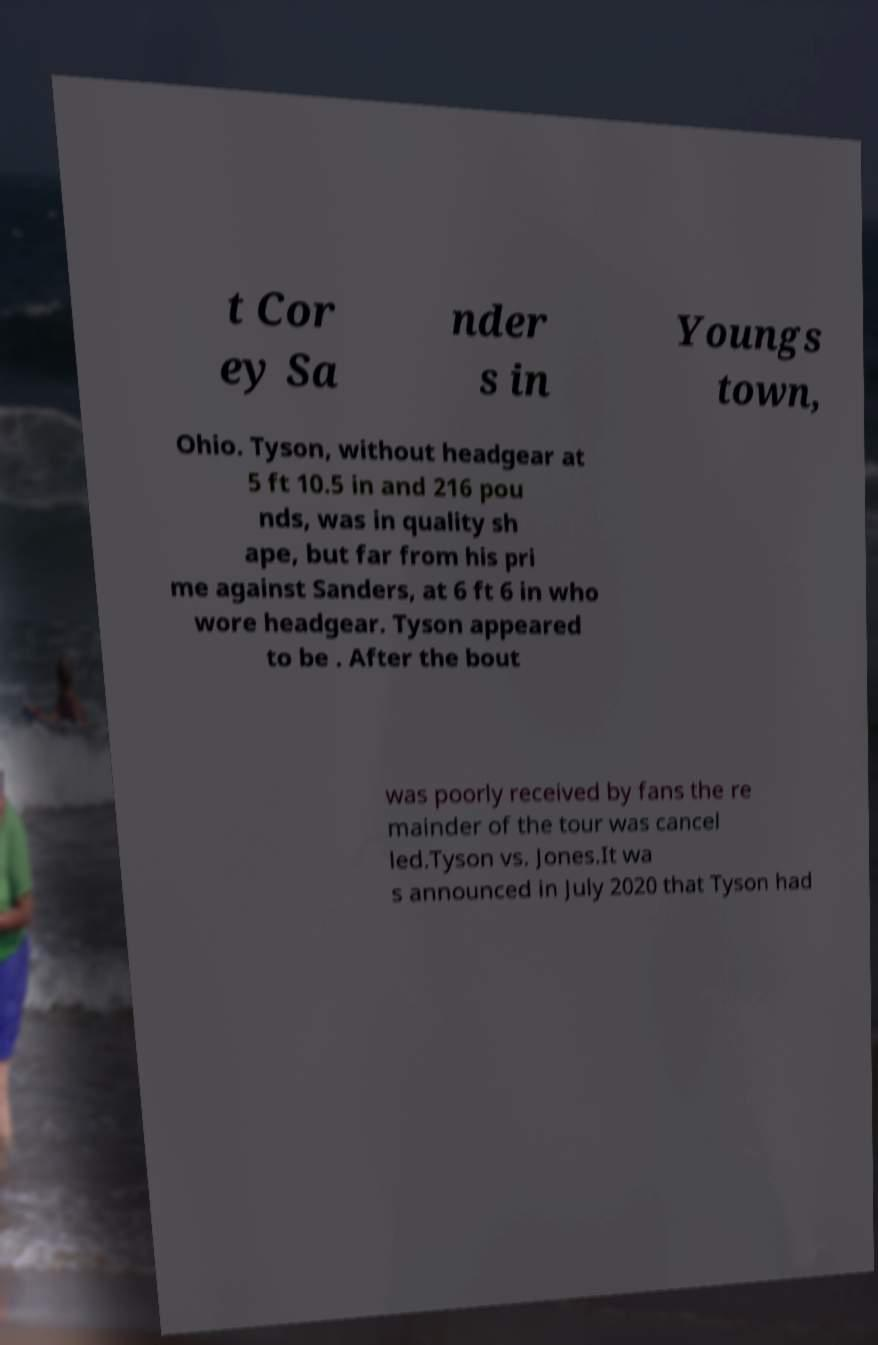Please read and relay the text visible in this image. What does it say? t Cor ey Sa nder s in Youngs town, Ohio. Tyson, without headgear at 5 ft 10.5 in and 216 pou nds, was in quality sh ape, but far from his pri me against Sanders, at 6 ft 6 in who wore headgear. Tyson appeared to be . After the bout was poorly received by fans the re mainder of the tour was cancel led.Tyson vs. Jones.It wa s announced in July 2020 that Tyson had 